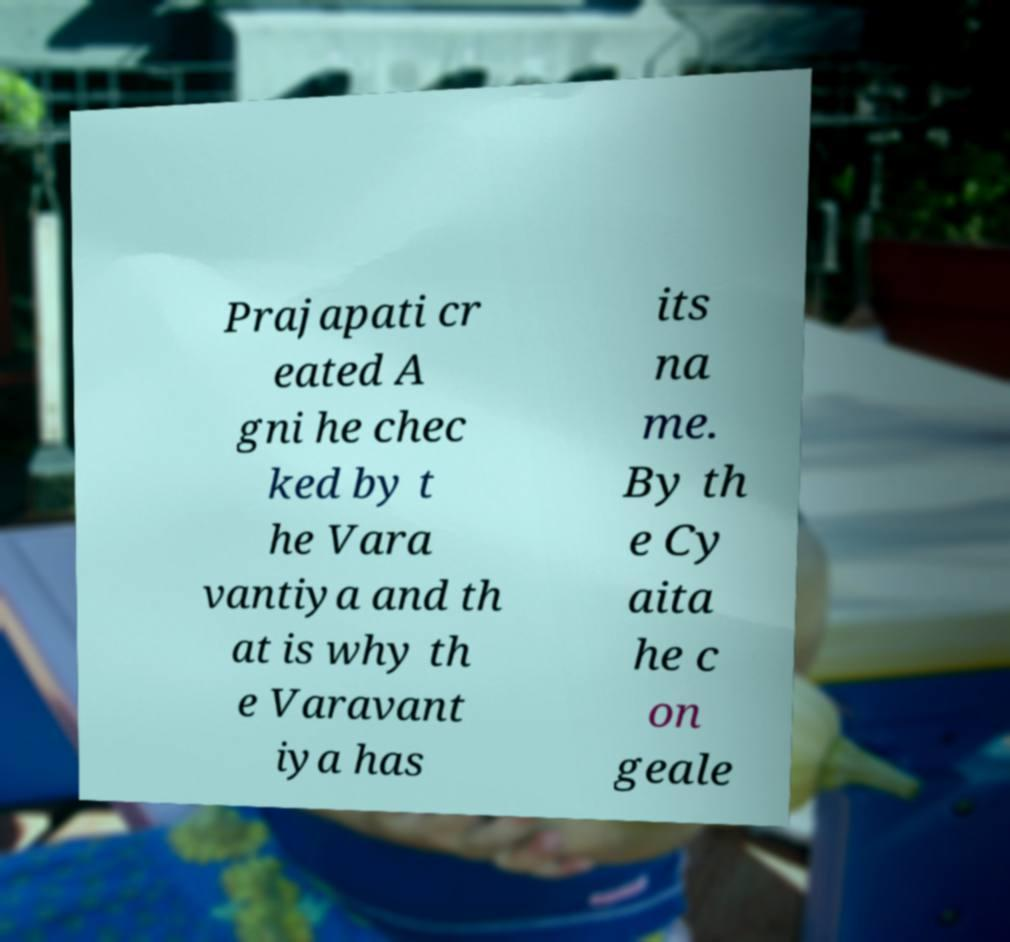Please read and relay the text visible in this image. What does it say? Prajapati cr eated A gni he chec ked by t he Vara vantiya and th at is why th e Varavant iya has its na me. By th e Cy aita he c on geale 